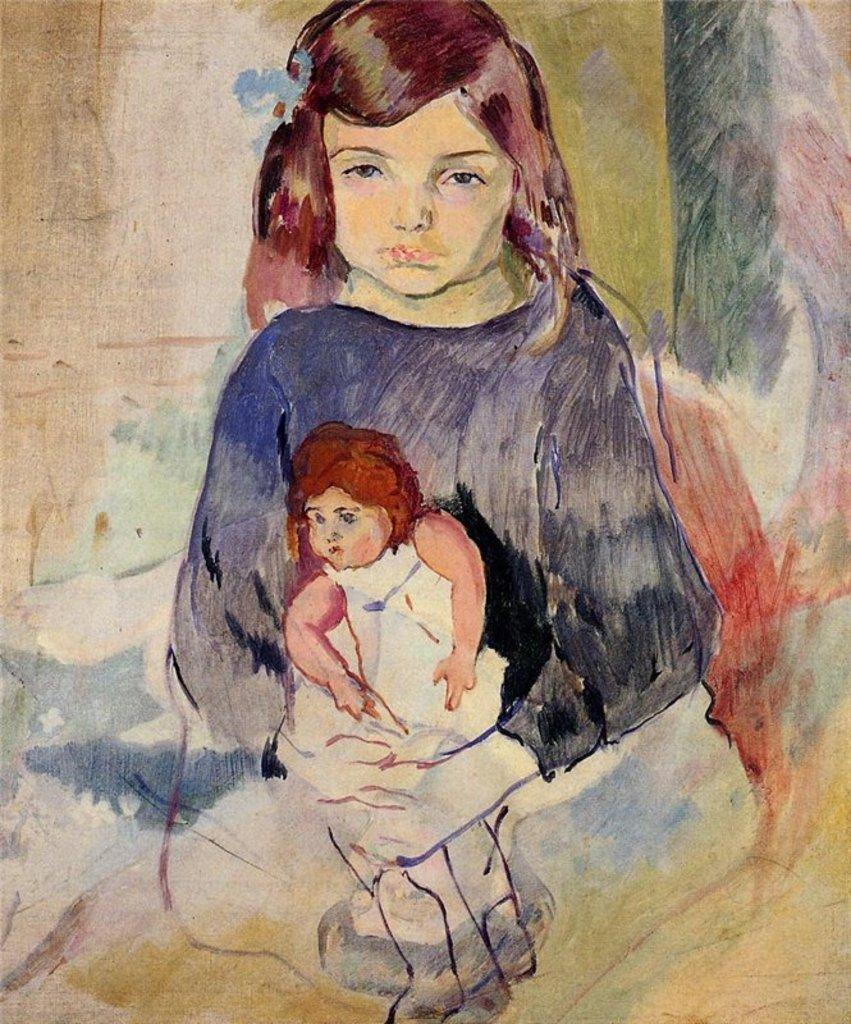What is depicted in the painting that is visible in the image? There is a painting of a girl in the image. What other object can be seen in the image besides the painting? There is a doll in the image. What type of skate is the girl using in the painting? There is no skate present in the painting or the image. Where is the canvas for the painting located in the image? The canvas for the painting is not visible in the image, as only the finished painting is shown. 